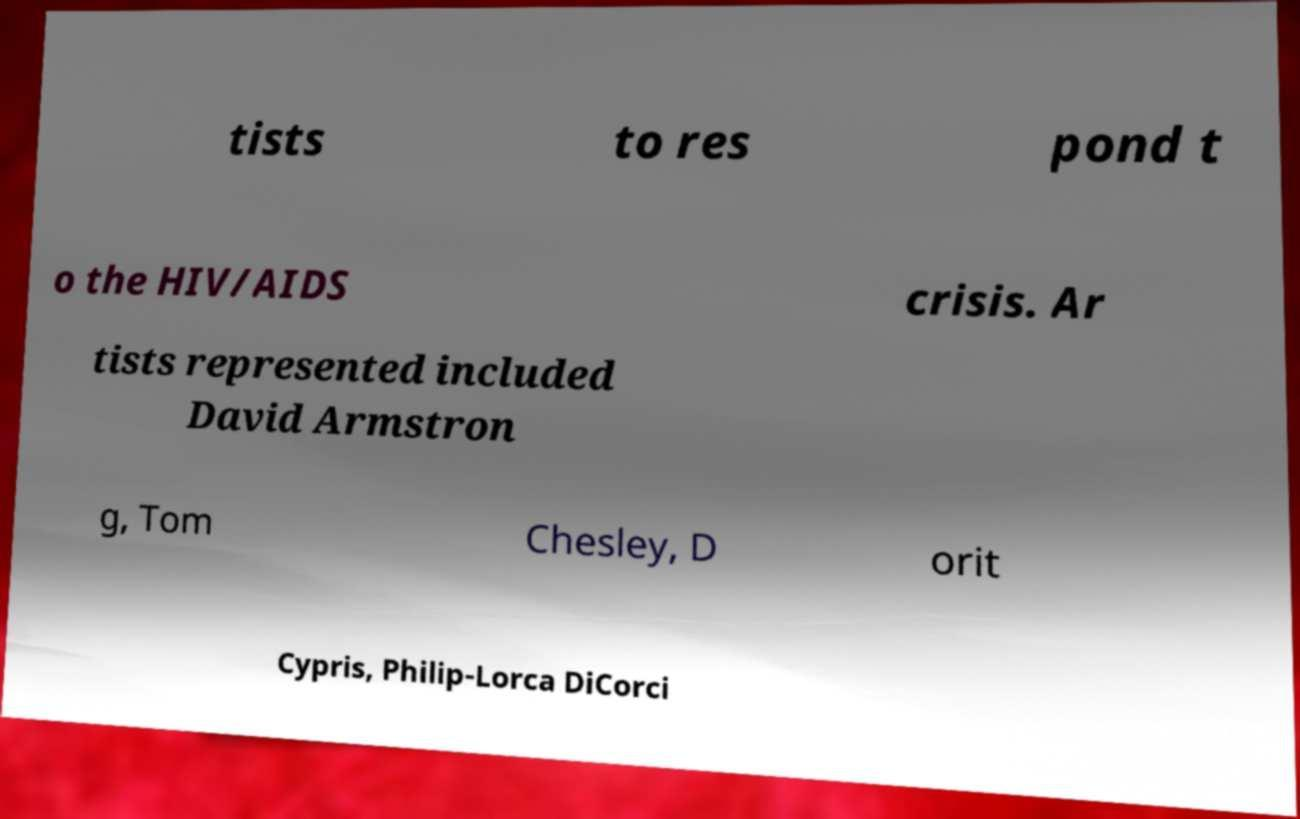Can you accurately transcribe the text from the provided image for me? tists to res pond t o the HIV/AIDS crisis. Ar tists represented included David Armstron g, Tom Chesley, D orit Cypris, Philip-Lorca DiCorci 